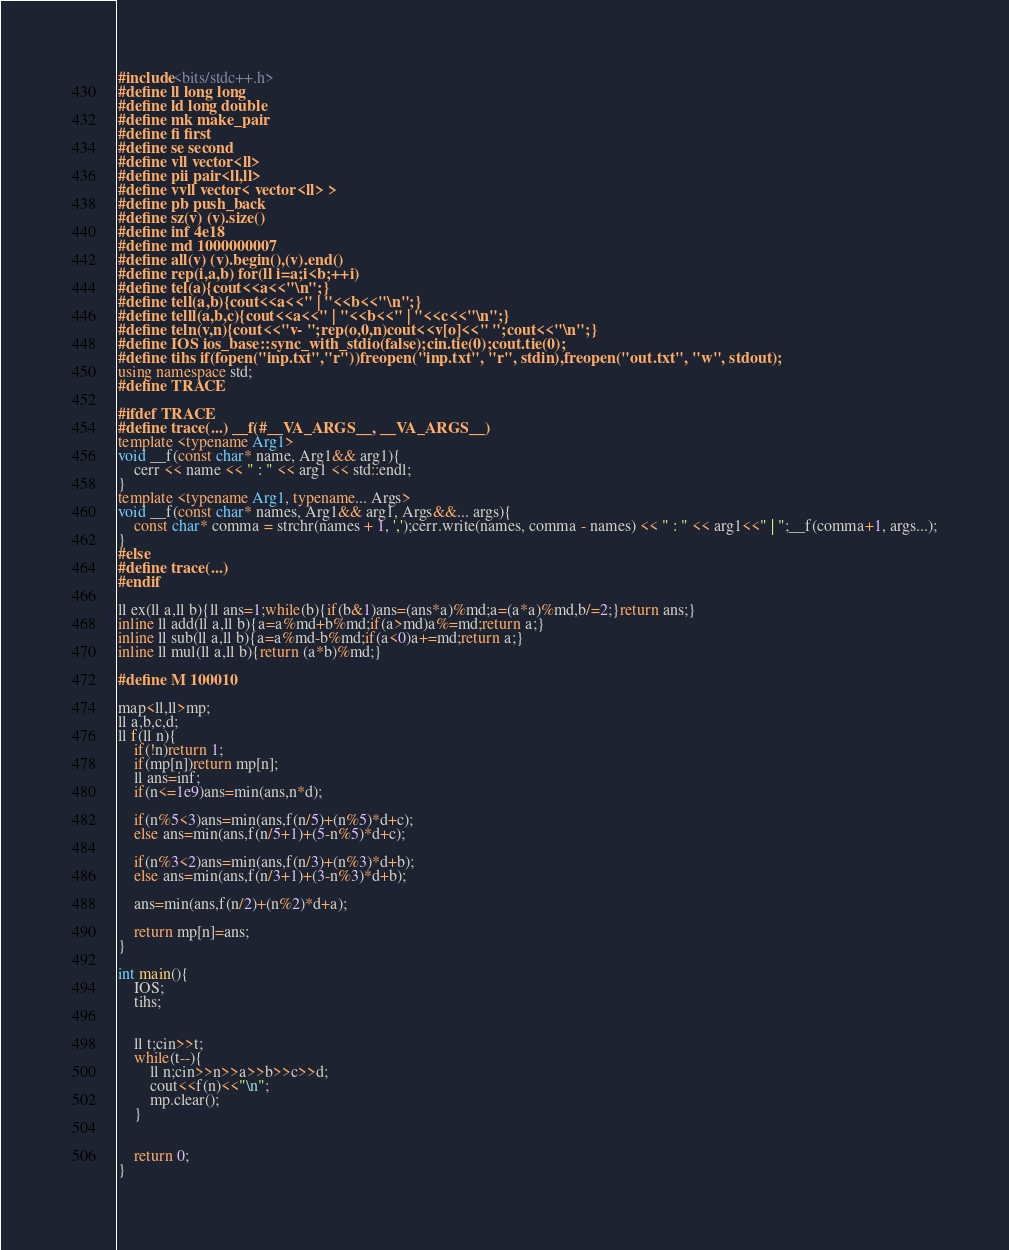<code> <loc_0><loc_0><loc_500><loc_500><_C++_>#include<bits/stdc++.h>
#define ll long long
#define ld long double
#define mk make_pair
#define fi first
#define se second
#define vll vector<ll>
#define pii pair<ll,ll>
#define vvll vector< vector<ll> >
#define pb push_back
#define sz(v) (v).size()
#define inf 4e18
#define md 1000000007
#define all(v) (v).begin(),(v).end()
#define rep(i,a,b) for(ll i=a;i<b;++i)
#define tel(a){cout<<a<<"\n";}
#define tell(a,b){cout<<a<<" | "<<b<<"\n";}
#define telll(a,b,c){cout<<a<<" | "<<b<<" | "<<c<<"\n";}
#define teln(v,n){cout<<"v- ";rep(o,0,n)cout<<v[o]<<" ";cout<<"\n";}
#define IOS ios_base::sync_with_stdio(false);cin.tie(0);cout.tie(0);
#define tihs if(fopen("inp.txt","r"))freopen("inp.txt", "r", stdin),freopen("out.txt", "w", stdout);
using namespace std;
#define TRACE
 
#ifdef TRACE
#define trace(...) __f(#__VA_ARGS__, __VA_ARGS__)
template <typename Arg1>
void __f(const char* name, Arg1&& arg1){
    cerr << name << " : " << arg1 << std::endl;
}
template <typename Arg1, typename... Args>
void __f(const char* names, Arg1&& arg1, Args&&... args){
    const char* comma = strchr(names + 1, ',');cerr.write(names, comma - names) << " : " << arg1<<" | ";__f(comma+1, args...);
}
#else
#define trace(...)
#endif
 
ll ex(ll a,ll b){ll ans=1;while(b){if(b&1)ans=(ans*a)%md;a=(a*a)%md,b/=2;}return ans;} 
inline ll add(ll a,ll b){a=a%md+b%md;if(a>md)a%=md;return a;}
inline ll sub(ll a,ll b){a=a%md-b%md;if(a<0)a+=md;return a;}
inline ll mul(ll a,ll b){return (a*b)%md;}

#define M 100010

map<ll,ll>mp;
ll a,b,c,d;
ll f(ll n){
	if(!n)return 1;
	if(mp[n])return mp[n];
	ll ans=inf;
	if(n<=1e9)ans=min(ans,n*d);
	
	if(n%5<3)ans=min(ans,f(n/5)+(n%5)*d+c);
	else ans=min(ans,f(n/5+1)+(5-n%5)*d+c);
	
	if(n%3<2)ans=min(ans,f(n/3)+(n%3)*d+b);
	else ans=min(ans,f(n/3+1)+(3-n%3)*d+b);
	
	ans=min(ans,f(n/2)+(n%2)*d+a);
	
	return mp[n]=ans;
}

int main(){
	IOS;
	tihs;

	
	ll t;cin>>t;
	while(t--){
		ll n;cin>>n>>a>>b>>c>>d;
		cout<<f(n)<<"\n";
		mp.clear();
	}
	
	
	return 0;
}</code> 